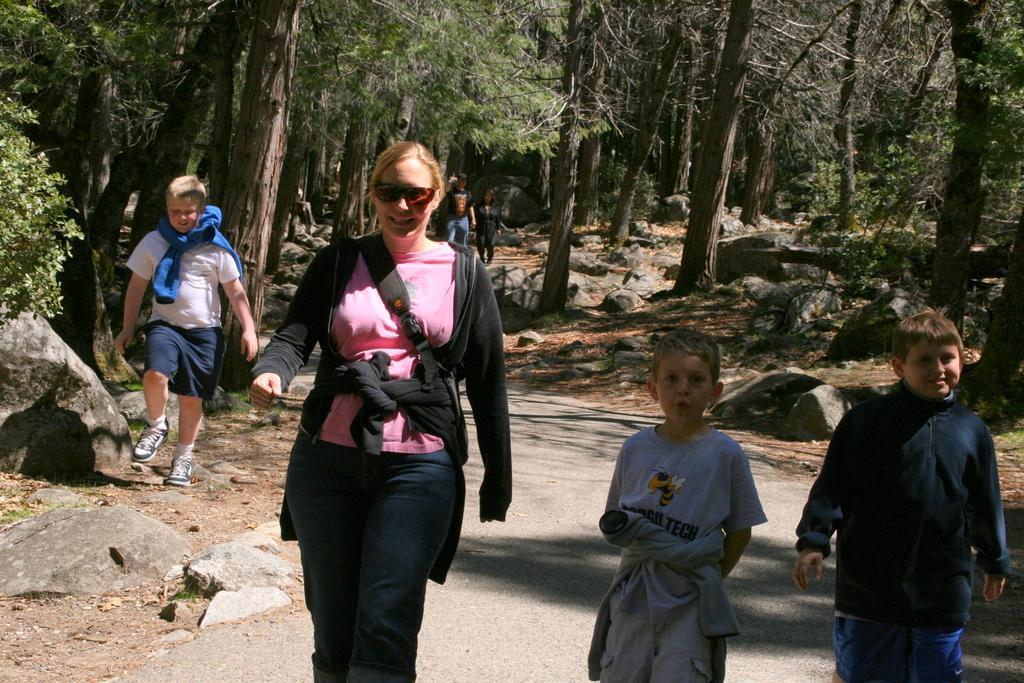In one or two sentences, can you explain what this image depicts? In this picture we can see some people walking on the ground, rocks and in the background we can see trees. 